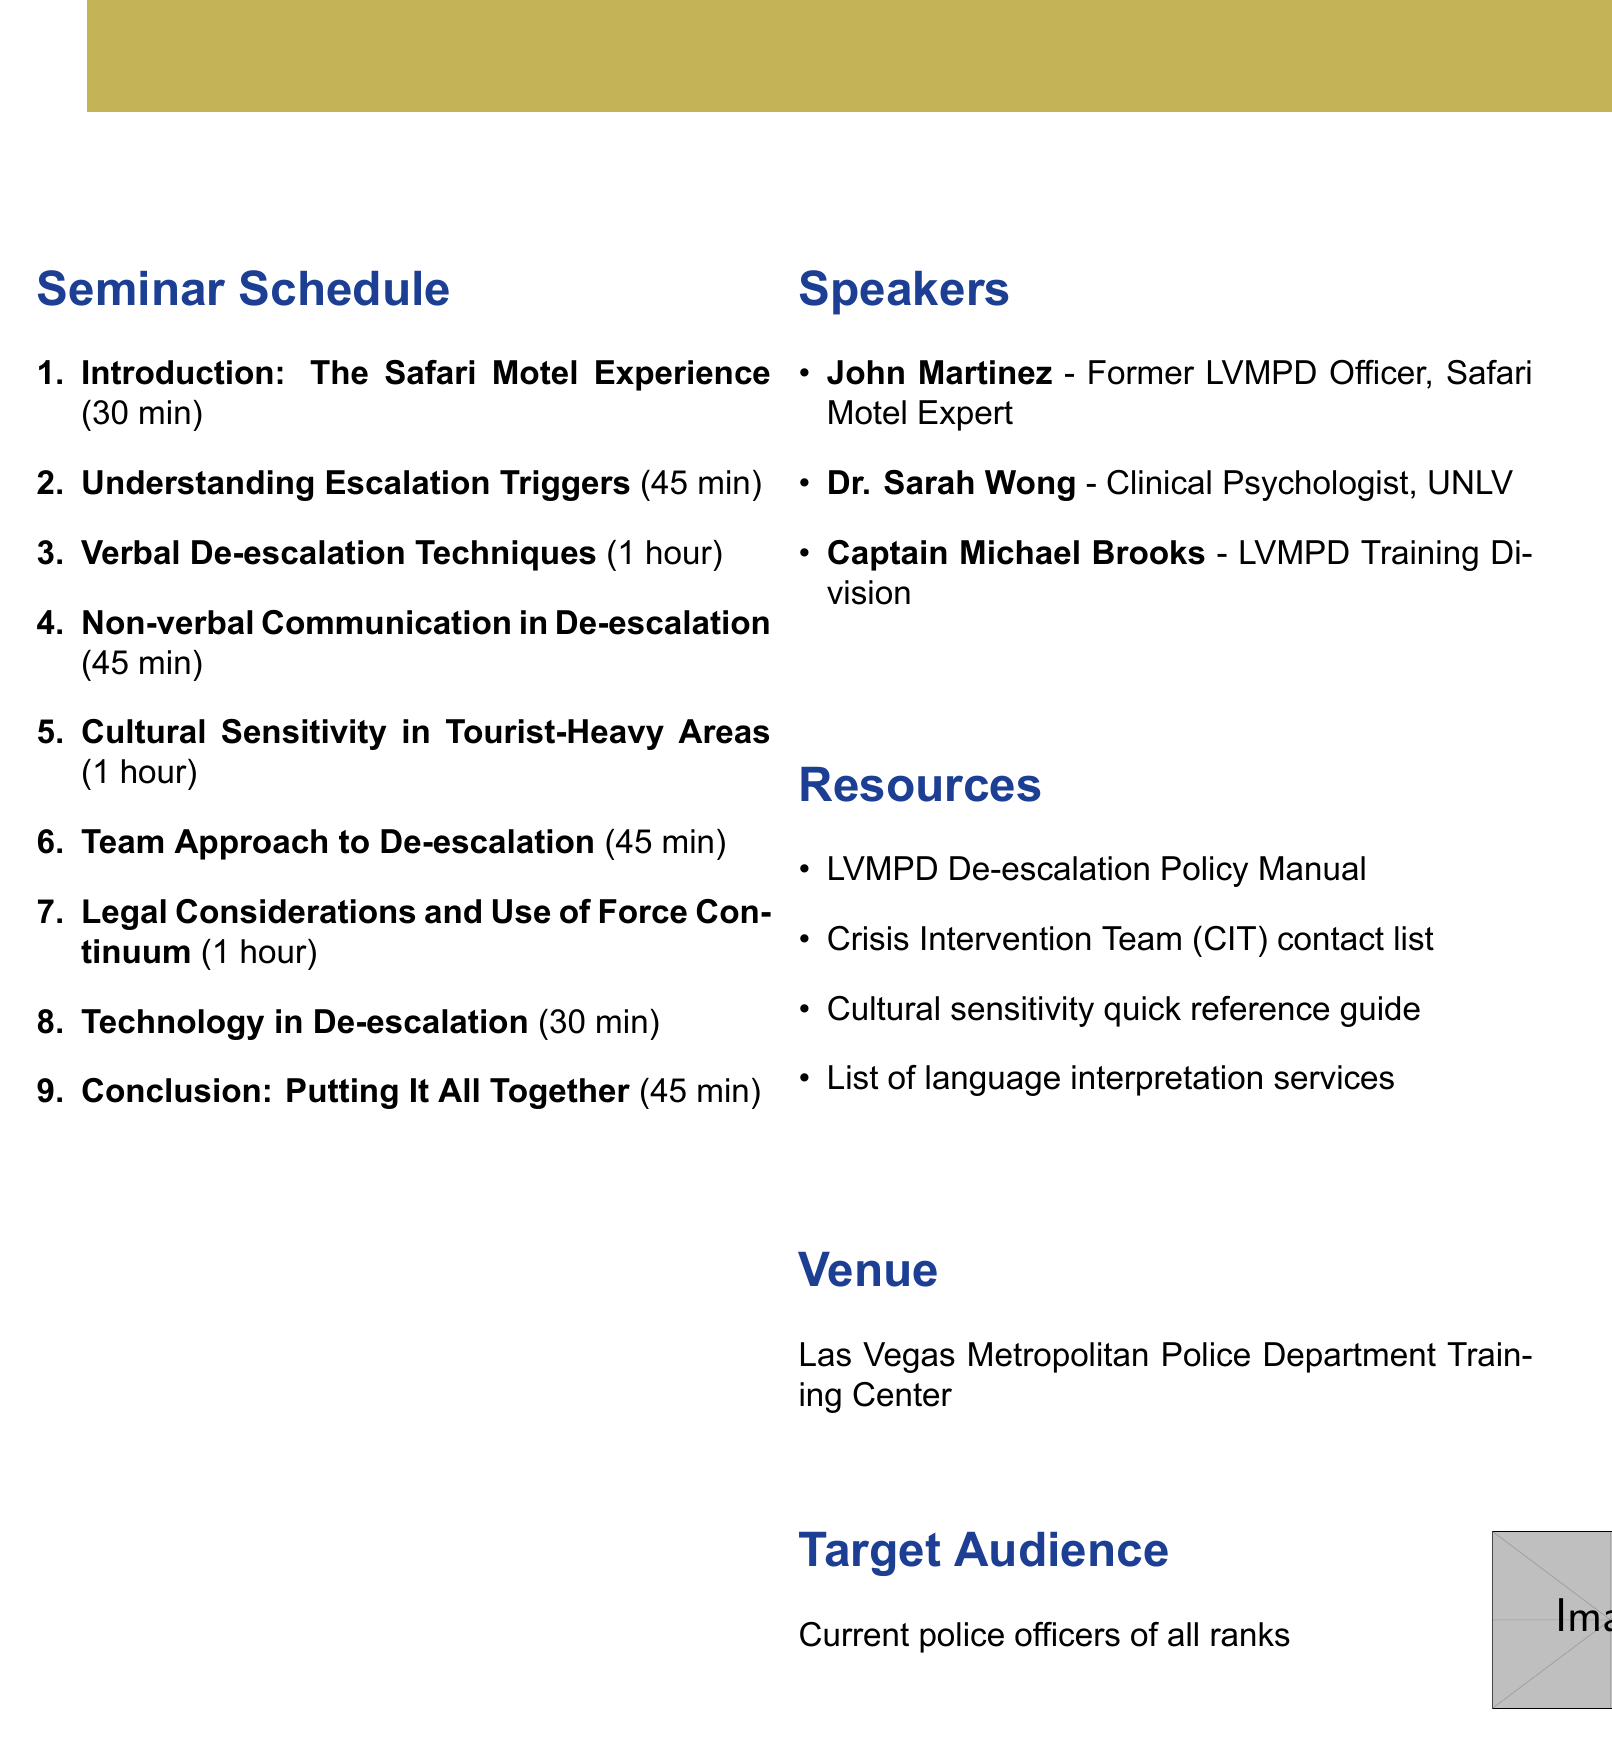what is the title of the seminar? The title is provided in the header of the document.
Answer: De-escalation Techniques: Lessons from the Vegas Strip when is the event date? The event date is indicated in the header section of the document.
Answer: September 15, 2023 where is the venue located? The venue is specified in the document under the venue section.
Answer: Las Vegas Metropolitan Police Department Training Center who is the first speaker listed? The first speaker's name is mentioned in the speakers section of the document.
Answer: John Martinez how long is the section on verbal de-escalation techniques? The duration for this section is provided in the seminar schedule.
Answer: 1 hour what percentage of the seminar schedule consists of cultural sensitivity training? Cultural sensitivity training is 1 hour out of a total of approximately 7 hours of seminar time.
Answer: About 14.3% what are participants expected to learn in the “Conclusion” section? This is outlined within the content of the Conclusion section.
Answer: Interactive scenario based on a complex Safari Motel call what type of resources are included in the seminar? This refers to the section listing supportive materials for the seminar.
Answer: LVMPD De-escalation Policy Manual, Crisis Intervention Team (CIT) contact list, Cultural sensitivity quick reference guide, List of language interpretation services available in Las Vegas who oversees the de-escalation training programs? This is indicated in the speakers section of the document.
Answer: Captain Michael Brooks 